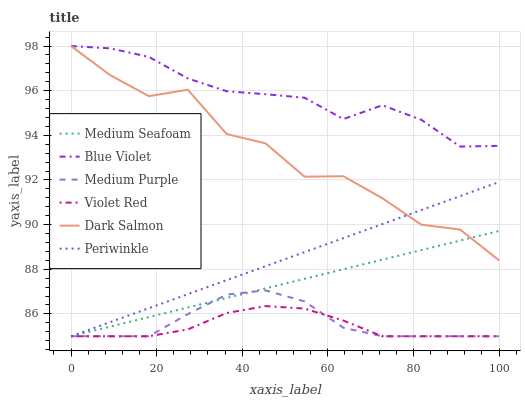Does Violet Red have the minimum area under the curve?
Answer yes or no. Yes. Does Blue Violet have the maximum area under the curve?
Answer yes or no. Yes. Does Dark Salmon have the minimum area under the curve?
Answer yes or no. No. Does Dark Salmon have the maximum area under the curve?
Answer yes or no. No. Is Periwinkle the smoothest?
Answer yes or no. Yes. Is Dark Salmon the roughest?
Answer yes or no. Yes. Is Medium Purple the smoothest?
Answer yes or no. No. Is Medium Purple the roughest?
Answer yes or no. No. Does Violet Red have the lowest value?
Answer yes or no. Yes. Does Dark Salmon have the lowest value?
Answer yes or no. No. Does Blue Violet have the highest value?
Answer yes or no. Yes. Does Medium Purple have the highest value?
Answer yes or no. No. Is Violet Red less than Dark Salmon?
Answer yes or no. Yes. Is Blue Violet greater than Medium Purple?
Answer yes or no. Yes. Does Medium Seafoam intersect Dark Salmon?
Answer yes or no. Yes. Is Medium Seafoam less than Dark Salmon?
Answer yes or no. No. Is Medium Seafoam greater than Dark Salmon?
Answer yes or no. No. Does Violet Red intersect Dark Salmon?
Answer yes or no. No. 